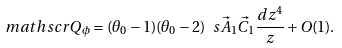<formula> <loc_0><loc_0><loc_500><loc_500>\ m a t h s c r { Q } _ { \phi } = ( \theta _ { 0 } - 1 ) ( \theta _ { 0 } - 2 ) \ s { \vec { A } _ { 1 } } { \vec { C } _ { 1 } } \frac { d z ^ { 4 } } { z } + O ( 1 ) .</formula> 